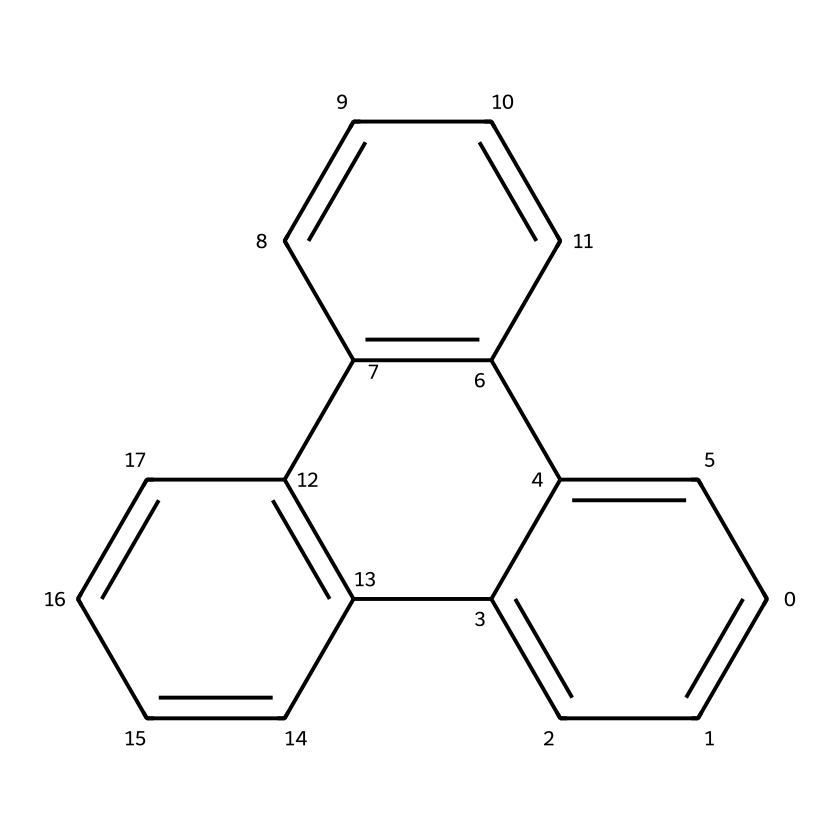How many carbon atoms are in the structure? By examining the SMILES representation, we count the carbon atoms. The notation 'C' represents carbon, and by analyzing the structure, we find that there are 18 distinct carbon atoms in total.
Answer: 18 What is the functional group present in these graphene quantum dots? Functional groups help identify the chemical behavior. In this case, the structure indicates that it is based on a polycyclic aromatic hydrocarbon, which has multiple fused benzene rings but does not display any additional functional groups directly.
Answer: polycyclic aromatic hydrocarbon How many double bonds are present in the structure? By analyzing the SMILES notation again, we can identify the double bonds, which are represented by “=”. Counting the instances of double bonds in the structure gives us a total of 9 double bonds present in this chemical.
Answer: 9 What is the approximate diameter of these quantum dots? Quantum dots are often characterized by their size, which can range from 1 to 10 nanometers. For graphene quantum dots like this representation, they typically fall within this range due to their structural properties being derived from graphene.
Answer: 1 to 10 nanometers How does the arrangement of the carbon atoms contribute to radiation resistance? The interconnected network of carbon atoms in the structure allows for delocalized pi electrons. This electron delocalization contributes to stability and enhances radiation resistance, as it helps in dispersing energy from radiation.
Answer: delocalized pi electrons What property makes graphene quantum dots suitable for radiation-resistant coatings? The high thermal conductivity and mechanical strength of graphene quantum dots stem from their unique atomic arrangement, allowing them to withstand high-energy radiation without significant degradation.
Answer: high thermal conductivity How many aromatic rings can be identified in this structure? By reviewing the structure, we note that each ring contains alternating double and single bonds, characteristic of aromatic structures. This compound contains a total of 4 aromatic rings.
Answer: 4 